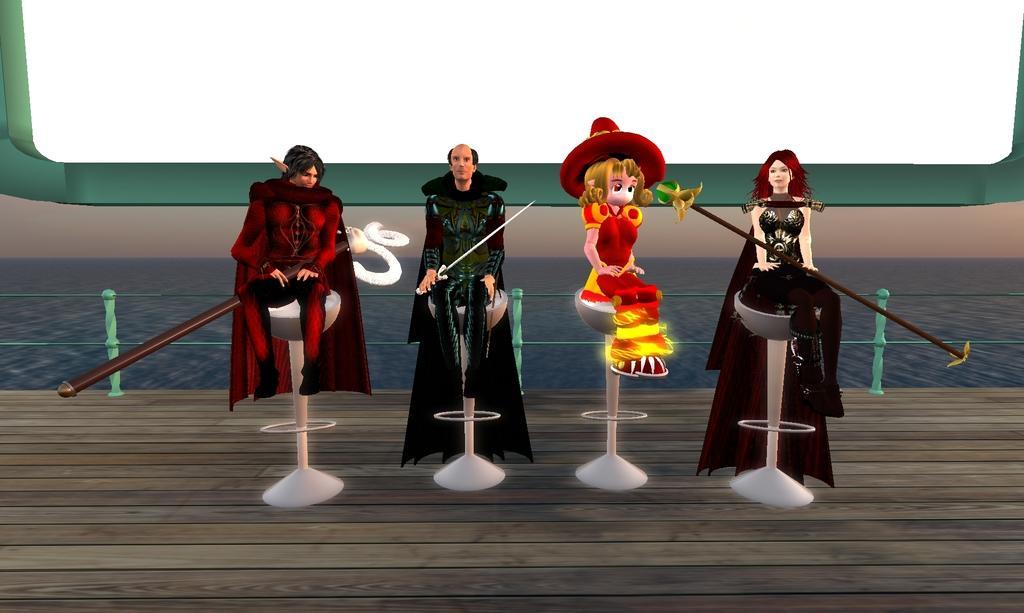Can you describe this image briefly? This is an animated image, there are four persons sitting, there are persons holding objects, there are chairs, there is a fencing truncated, there is a wall behind the persons, there is a screen truncated towards the top of the image. 